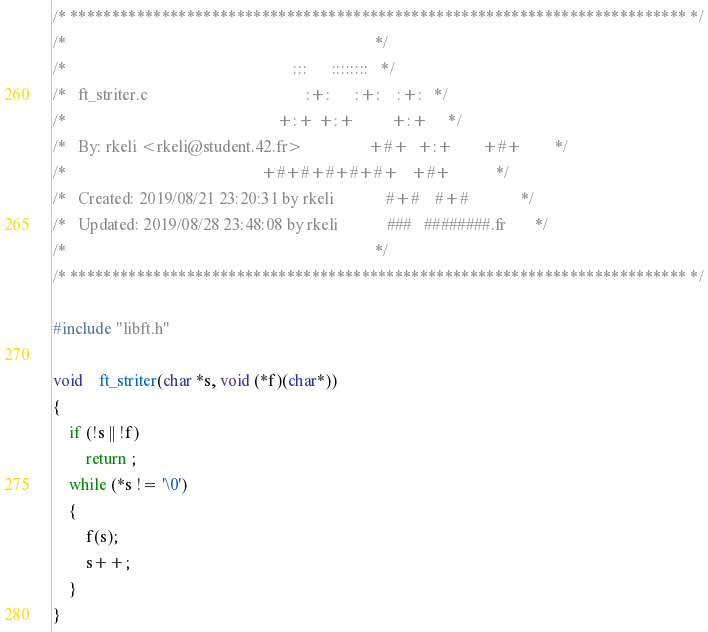<code> <loc_0><loc_0><loc_500><loc_500><_C_>/* ************************************************************************** */
/*                                                                            */
/*                                                        :::      ::::::::   */
/*   ft_striter.c                                       :+:      :+:    :+:   */
/*                                                    +:+ +:+         +:+     */
/*   By: rkeli <rkeli@student.42.fr>                +#+  +:+       +#+        */
/*                                                +#+#+#+#+#+   +#+           */
/*   Created: 2019/08/21 23:20:31 by rkeli             #+#    #+#             */
/*   Updated: 2019/08/28 23:48:08 by rkeli            ###   ########.fr       */
/*                                                                            */
/* ************************************************************************** */

#include "libft.h"

void	ft_striter(char *s, void (*f)(char*))
{
	if (!s || !f)
		return ;
	while (*s != '\0')
	{
		f(s);
		s++;
	}
}
</code> 